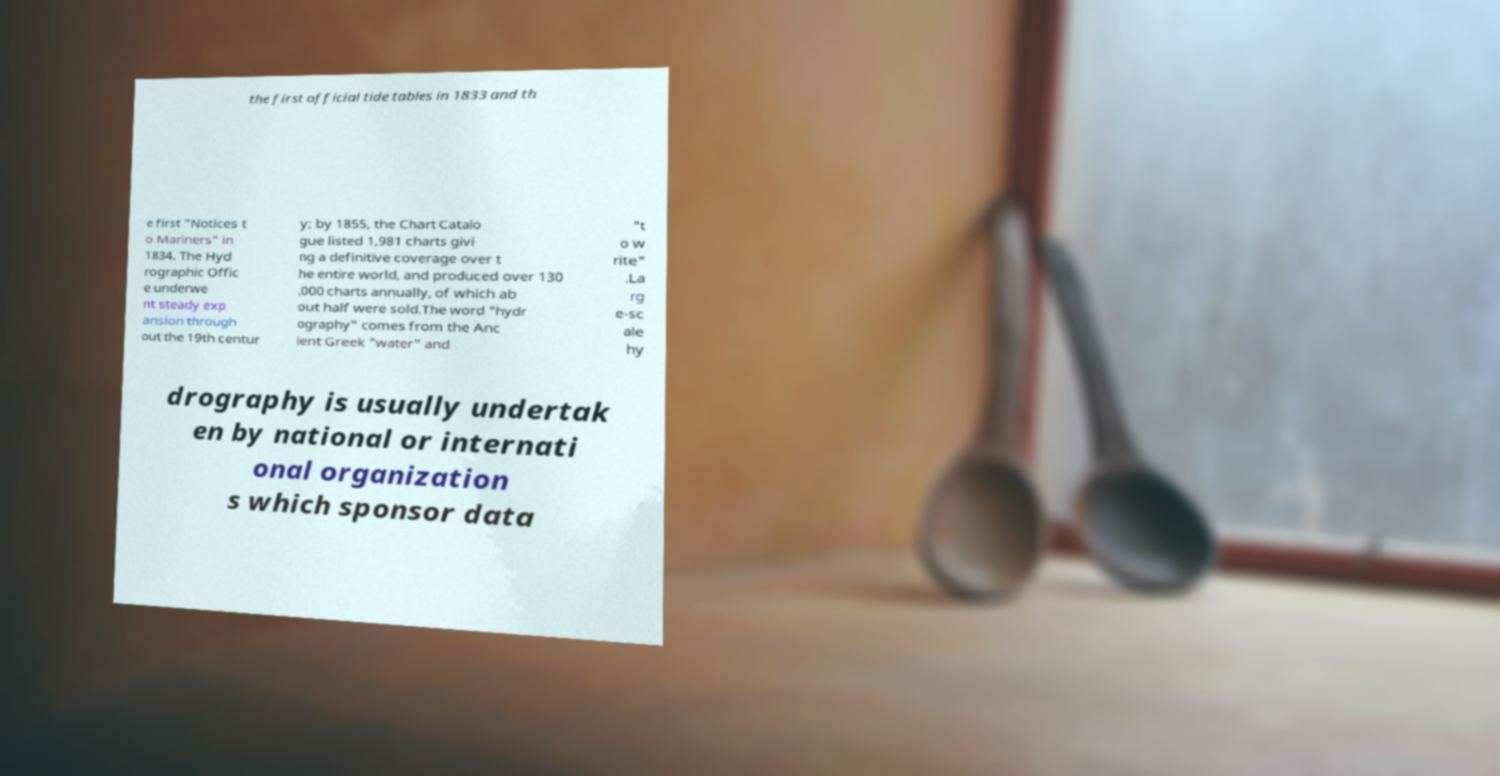There's text embedded in this image that I need extracted. Can you transcribe it verbatim? the first official tide tables in 1833 and th e first "Notices t o Mariners" in 1834. The Hyd rographic Offic e underwe nt steady exp ansion through out the 19th centur y; by 1855, the Chart Catalo gue listed 1,981 charts givi ng a definitive coverage over t he entire world, and produced over 130 ,000 charts annually, of which ab out half were sold.The word "hydr ography" comes from the Anc ient Greek "water" and "t o w rite" .La rg e-sc ale hy drography is usually undertak en by national or internati onal organization s which sponsor data 